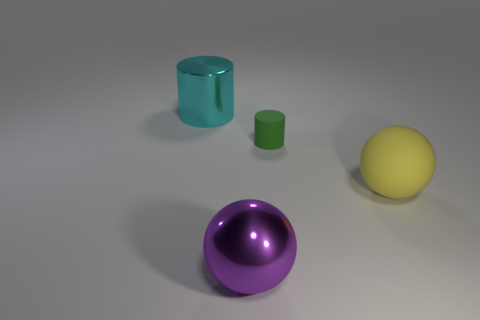Subtract 2 spheres. How many spheres are left? 0 Subtract all red cylinders. Subtract all yellow balls. How many cylinders are left? 2 Subtract all red blocks. How many purple spheres are left? 1 Subtract all metal cylinders. Subtract all large purple shiny things. How many objects are left? 2 Add 4 large metal things. How many large metal things are left? 6 Add 1 green cylinders. How many green cylinders exist? 2 Add 2 big cyan metal cylinders. How many objects exist? 6 Subtract 0 red cubes. How many objects are left? 4 